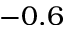<formula> <loc_0><loc_0><loc_500><loc_500>- 0 . 6</formula> 